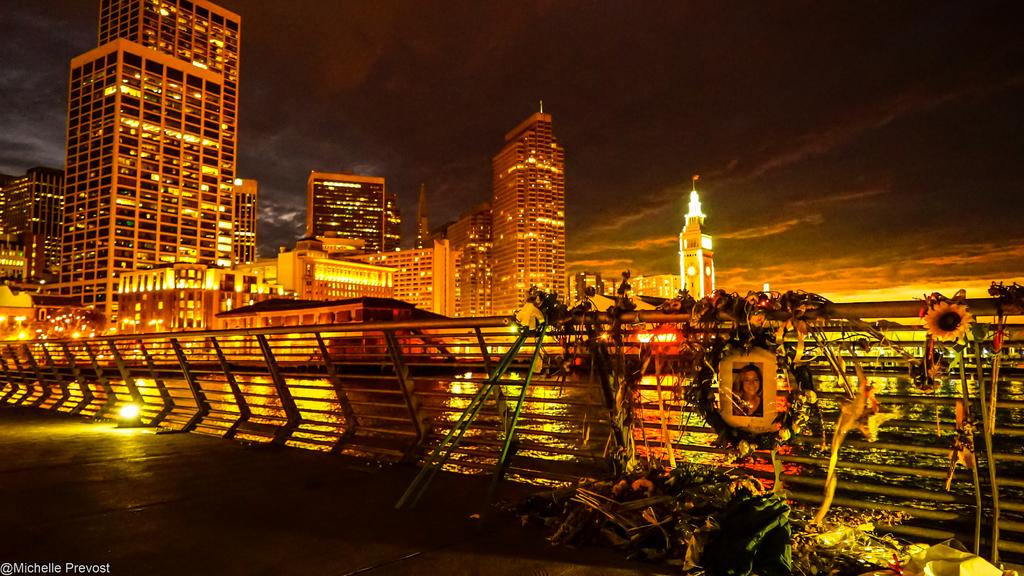What type of scene is depicted in the image? The image shows an outer view of a city. What structures can be seen in the image? There are buildings and towers in the image. What natural feature is present in the image? There is a river in the image. What man-made structure can be seen crossing the river? There is a bridge in the image. What type of vegetation is present in the image? Creepers and flowers are visible in the image. What additional item is present in the image? There is a photograph in the image. What type of ear is visible on the bridge in the image? There is no ear present on the bridge or anywhere else in the image. Who is the representative of the city in the image? The image does not depict any specific individuals or representatives of the city. 